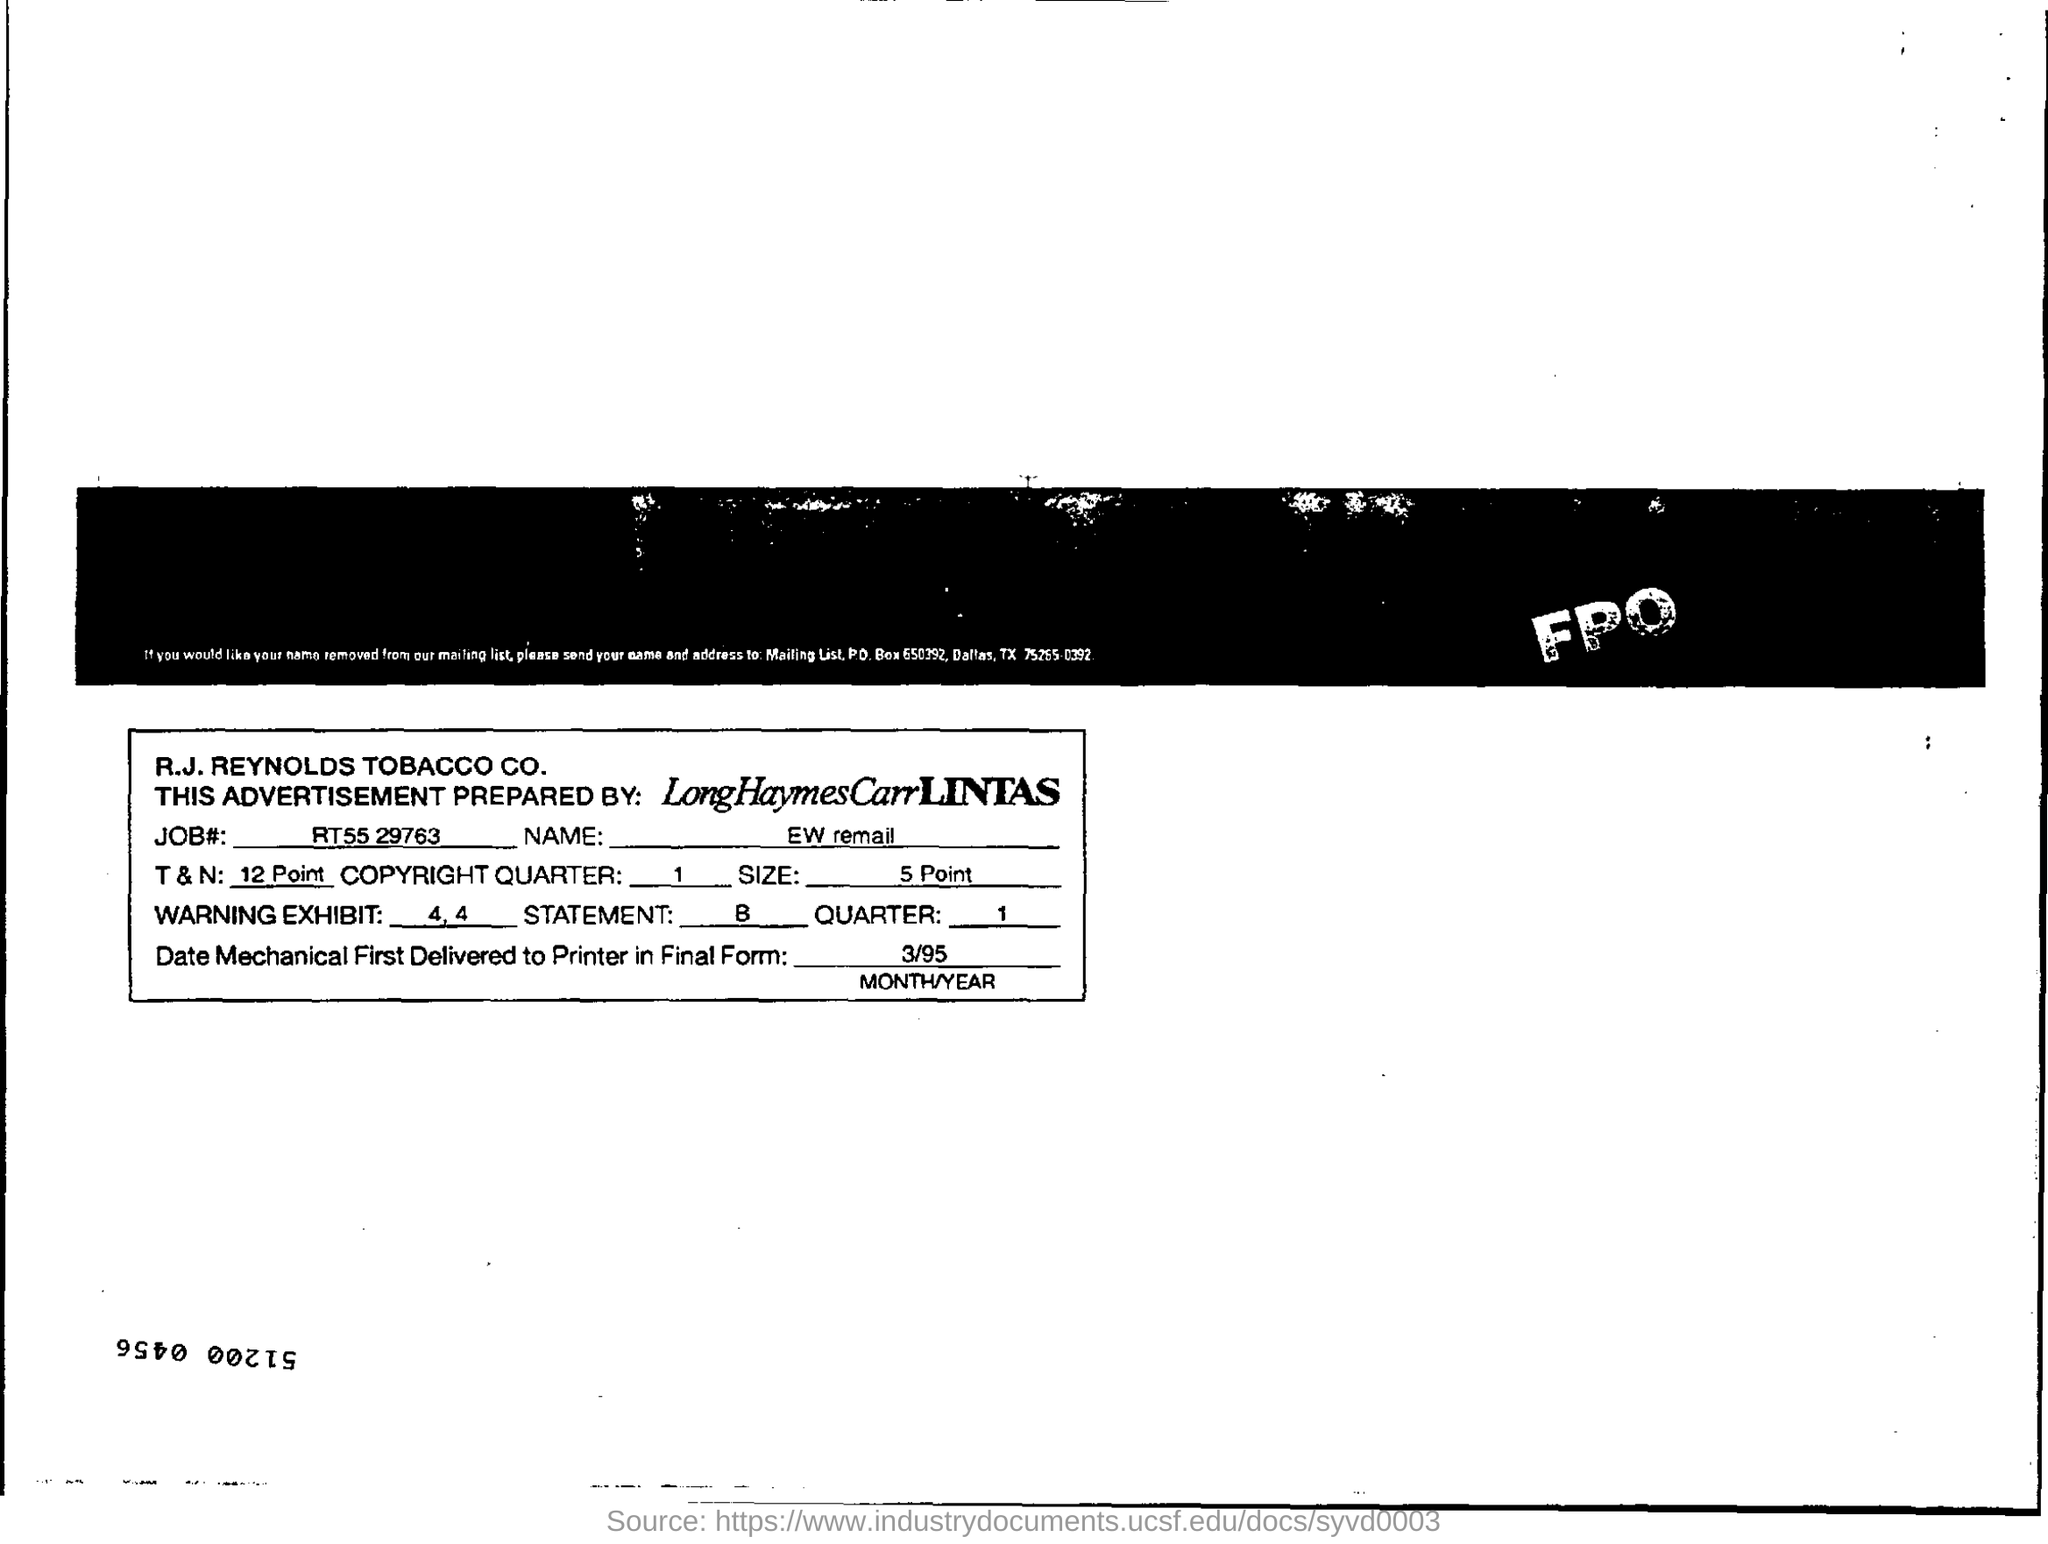Who  prepared this Advertisement  ?
Your answer should be compact. LongHaymesCarrLINTAS. What is the Size ?
Offer a terse response. 5 point. What is the JOB Number ?
Provide a short and direct response. RT55 29763. 